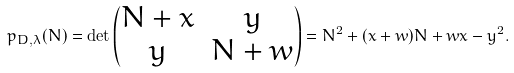<formula> <loc_0><loc_0><loc_500><loc_500>p _ { D , \lambda } ( N ) = \det \left ( \begin{matrix} N + x & y \\ y & N + w \end{matrix} \right ) = N ^ { 2 } + ( x + w ) N + w x - y ^ { 2 } .</formula> 